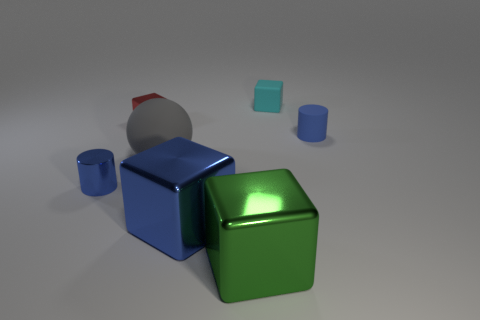Subtract all large blue cubes. How many cubes are left? 3 Subtract all blue cubes. How many cubes are left? 3 Subtract 2 cubes. How many cubes are left? 2 Subtract all spheres. How many objects are left? 6 Subtract 1 gray spheres. How many objects are left? 6 Subtract all yellow spheres. Subtract all cyan cylinders. How many spheres are left? 1 Subtract all gray cylinders. How many blue cubes are left? 1 Subtract all yellow things. Subtract all large things. How many objects are left? 4 Add 7 cyan things. How many cyan things are left? 8 Add 2 large gray balls. How many large gray balls exist? 3 